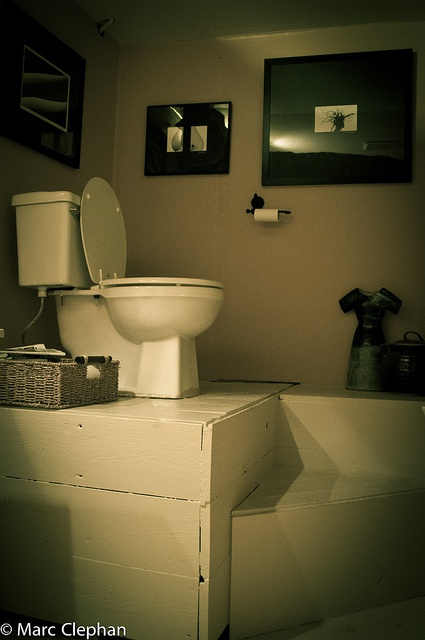Describe the objects in this image and their specific colors. I can see a toilet in black, tan, and olive tones in this image. 